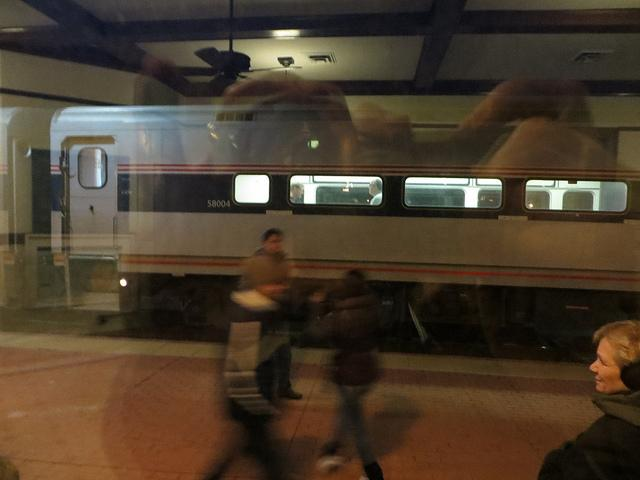How many people are walking around in the train station? Please explain your reasoning. three. The people are visible and countable based on their unique outlines. 